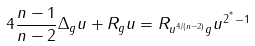Convert formula to latex. <formula><loc_0><loc_0><loc_500><loc_500>4 \frac { n - 1 } { n - 2 } \Delta _ { g } u + R _ { g } u = R _ { u ^ { 4 / ( n - 2 ) } g } u ^ { 2 ^ { ^ { * } } - 1 }</formula> 